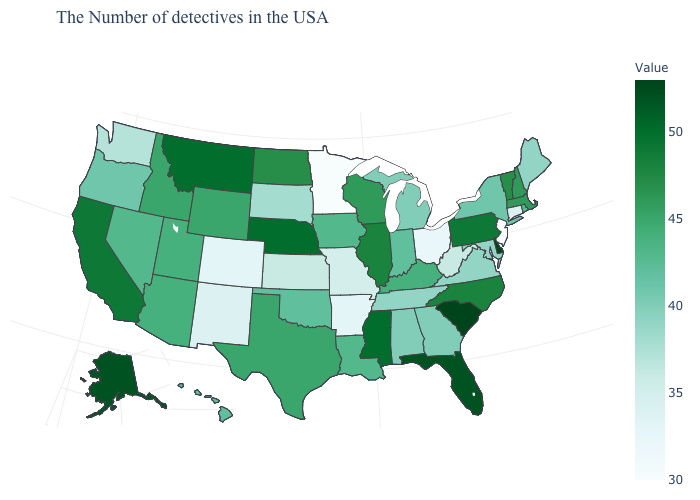Which states have the lowest value in the USA?
Answer briefly. New Jersey, Minnesota. Among the states that border Idaho , does Washington have the lowest value?
Quick response, please. Yes. Is the legend a continuous bar?
Write a very short answer. Yes. Does Alaska have the highest value in the West?
Short answer required. Yes. Which states have the lowest value in the USA?
Quick response, please. New Jersey, Minnesota. 